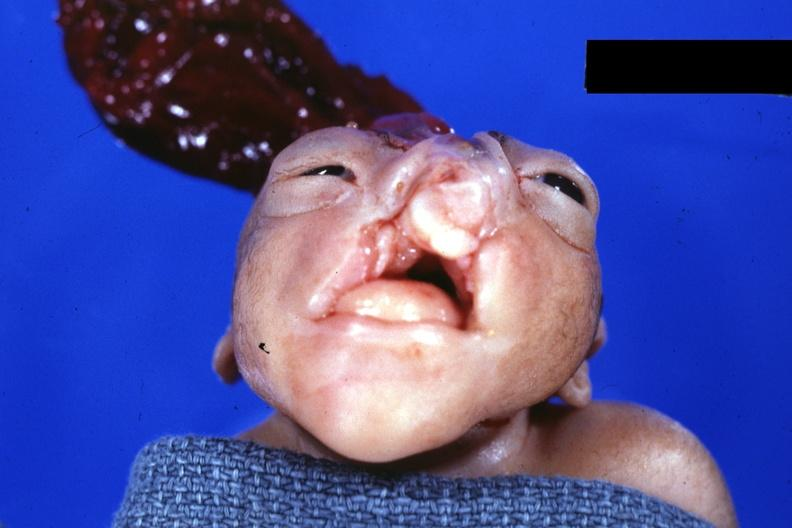does thecoma show frontal view close-up?
Answer the question using a single word or phrase. No 